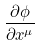Convert formula to latex. <formula><loc_0><loc_0><loc_500><loc_500>\frac { \partial \phi } { \partial x ^ { \mu } }</formula> 